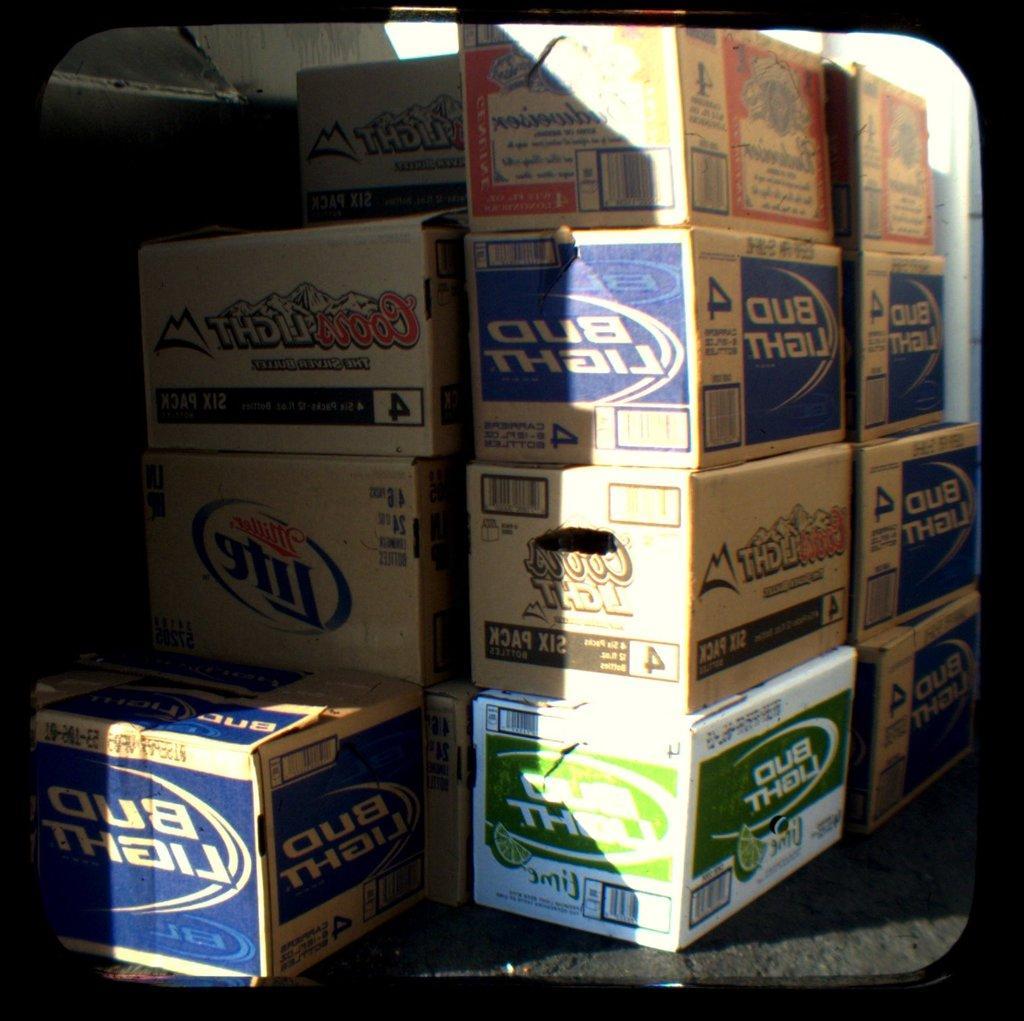Describe this image in one or two sentences. In the image there are a set of boxes containing some items, they are arranged in an order. 